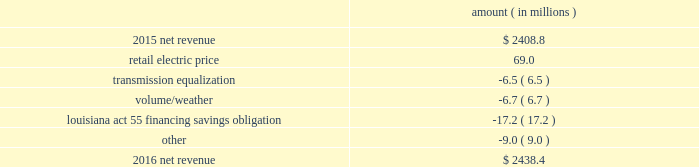Entergy louisiana , llc and subsidiaries management 2019s financial discussion and analysis results of operations net income 2016 compared to 2015 net income increased $ 175.4 million primarily due to the effect of a settlement with the irs related to the 2010-2011 irs audit , which resulted in a $ 136.1 million reduction of income tax expense .
Also contributing to the increase were lower other operation and maintenance expenses , higher net revenue , and higher other income .
The increase was partially offset by higher depreciation and amortization expenses , higher interest expense , and higher nuclear refueling outage expenses .
2015 compared to 2014 net income increased slightly , by $ 0.6 million , primarily due to higher net revenue and a lower effective income tax rate , offset by higher other operation and maintenance expenses , higher depreciation and amortization expenses , lower other income , and higher interest expense .
Net revenue 2016 compared to 2015 net revenue consists of operating revenues net of : 1 ) fuel , fuel-related expenses , and gas purchased for resale , 2 ) purchased power expenses , and 3 ) other regulatory charges .
Following is an analysis of the change in net revenue comparing 2016 to 2015 .
Amount ( in millions ) .
The retail electric price variance is primarily due to an increase in formula rate plan revenues , implemented with the first billing cycle of march 2016 , to collect the estimated first-year revenue requirement related to the purchase of power blocks 3 and 4 of the union power station .
See note 2 to the financial statements for further discussion .
The transmission equalization variance is primarily due to changes in transmission investments , including entergy louisiana 2019s exit from the system agreement in august 2016 .
The volume/weather variance is primarily due to the effect of less favorable weather on residential sales , partially offset by an increase in industrial usage and an increase in volume during the unbilled period .
The increase .
If the same changes to net income that occured in 2015 compared to 2014 recurred in 2016 , what would 2016 net revenue have been? 
Computations: (0.6 + 2438.4)
Answer: 2439.0. 